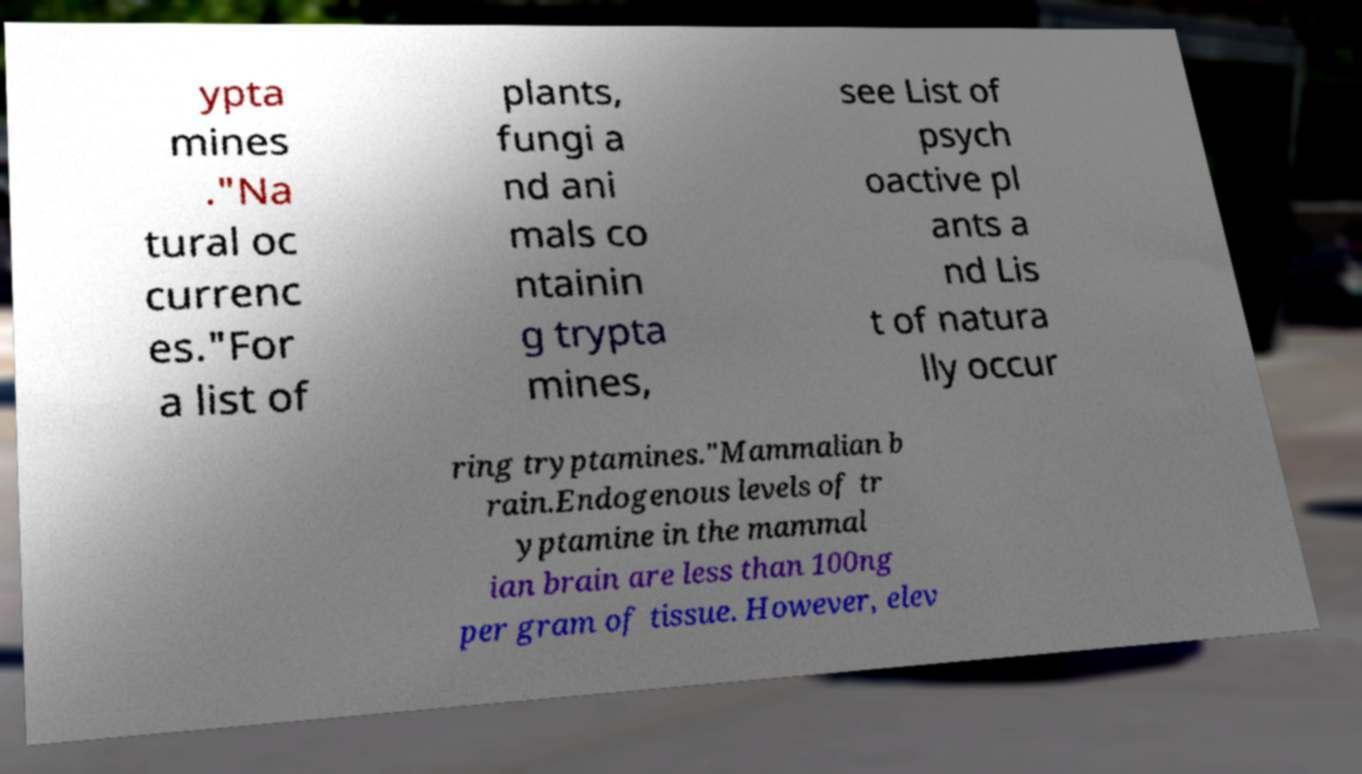There's text embedded in this image that I need extracted. Can you transcribe it verbatim? ypta mines ."Na tural oc currenc es."For a list of plants, fungi a nd ani mals co ntainin g trypta mines, see List of psych oactive pl ants a nd Lis t of natura lly occur ring tryptamines."Mammalian b rain.Endogenous levels of tr yptamine in the mammal ian brain are less than 100ng per gram of tissue. However, elev 